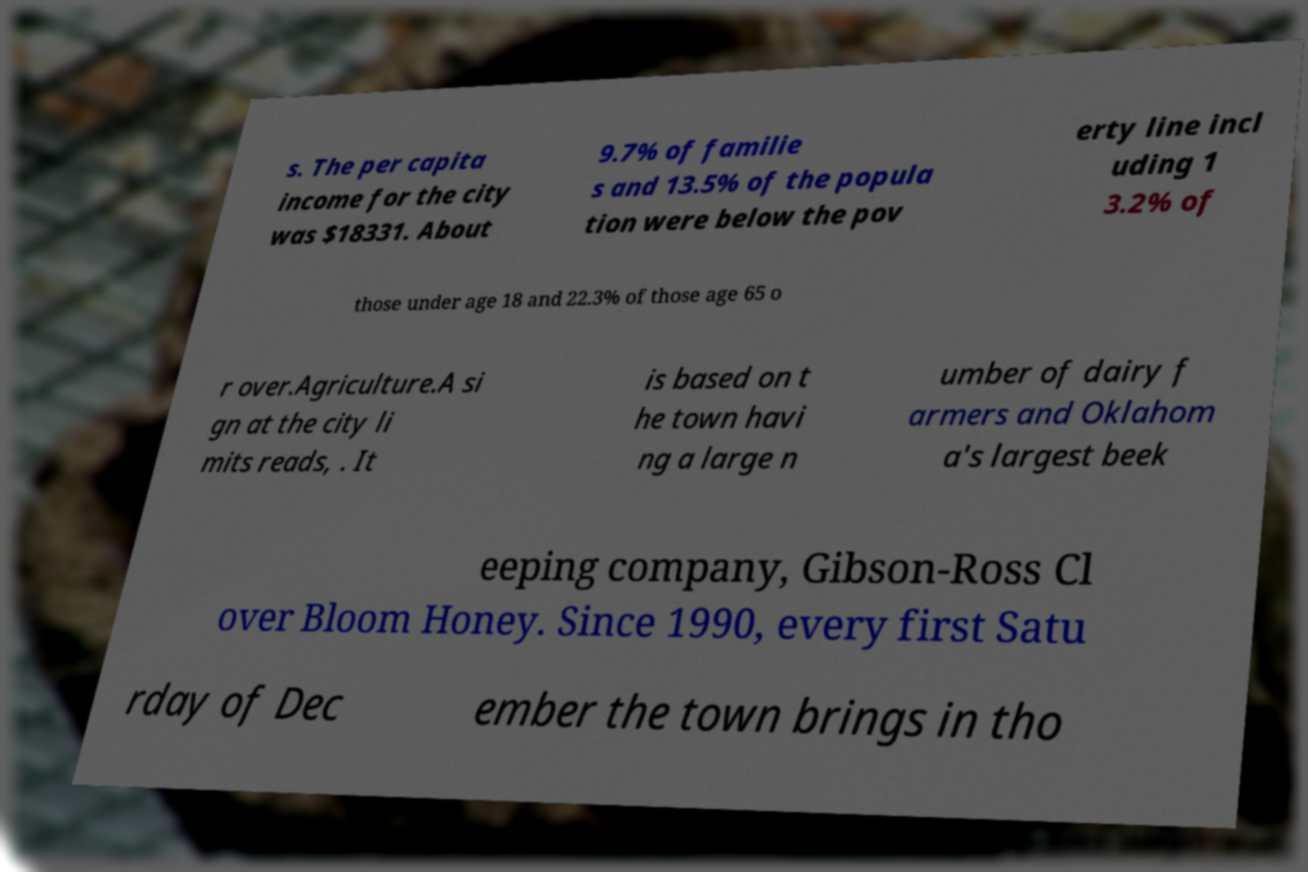Could you assist in decoding the text presented in this image and type it out clearly? s. The per capita income for the city was $18331. About 9.7% of familie s and 13.5% of the popula tion were below the pov erty line incl uding 1 3.2% of those under age 18 and 22.3% of those age 65 o r over.Agriculture.A si gn at the city li mits reads, . It is based on t he town havi ng a large n umber of dairy f armers and Oklahom a's largest beek eeping company, Gibson-Ross Cl over Bloom Honey. Since 1990, every first Satu rday of Dec ember the town brings in tho 